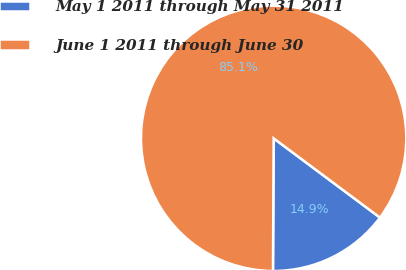<chart> <loc_0><loc_0><loc_500><loc_500><pie_chart><fcel>May 1 2011 through May 31 2011<fcel>June 1 2011 through June 30<nl><fcel>14.89%<fcel>85.11%<nl></chart> 